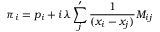Convert formula to latex. <formula><loc_0><loc_0><loc_500><loc_500>\pi _ { i } = p _ { i } + i \lambda \sum _ { j } ^ { \prime } { \frac { 1 } { ( x _ { i } - x _ { j } ) } } M _ { i j }</formula> 